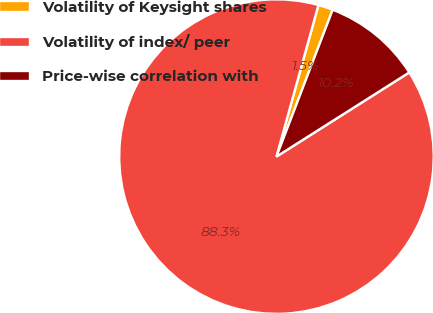<chart> <loc_0><loc_0><loc_500><loc_500><pie_chart><fcel>Volatility of Keysight shares<fcel>Volatility of index/ peer<fcel>Price-wise correlation with<nl><fcel>1.52%<fcel>88.29%<fcel>10.19%<nl></chart> 